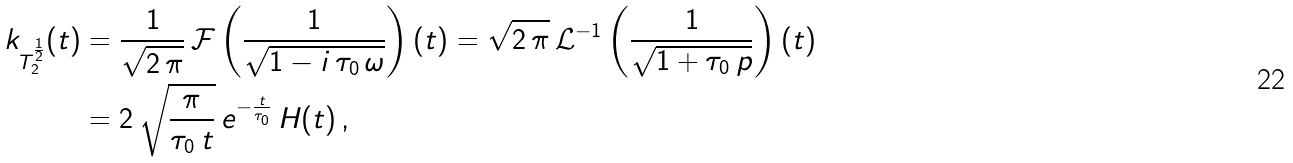<formula> <loc_0><loc_0><loc_500><loc_500>k _ { T _ { 2 } ^ { \frac { 1 } { 2 } } } ( t ) & = \frac { 1 } { \sqrt { 2 \, \pi } } \, \mathcal { F } \left ( \frac { 1 } { \sqrt { 1 - i \, \tau _ { 0 } \, \omega } } \right ) ( t ) = \sqrt { 2 \, \pi } \, \mathcal { L } ^ { - 1 } \left ( \frac { 1 } { \sqrt { 1 + \tau _ { 0 } \, p } } \right ) ( t ) \\ & = 2 \, \sqrt { \frac { \pi } { \tau _ { 0 } \, t } } \, e ^ { - \frac { t } { \tau _ { 0 } } } \, H ( t ) \, ,</formula> 